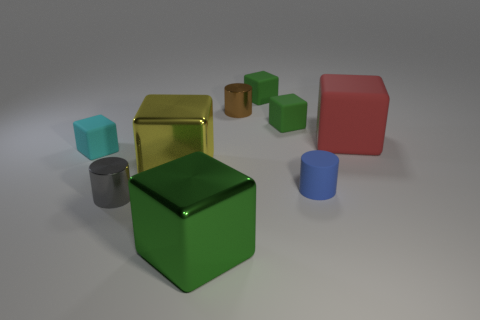There is a tiny cyan thing that is the same shape as the large red matte thing; what is it made of? Based on the image, the tiny cyan object resembles the large red object in shape, which suggests they might be made of similar materials. Commonly such objects in visual representations could be made from a variety of materials including plastic, wood, or metal, each finished with different textures or coatings to achieve a particular look. However, without specific details or context that indicate the material composition in the image, we cannot conclude definitively what the tiny cyan object is made of. 